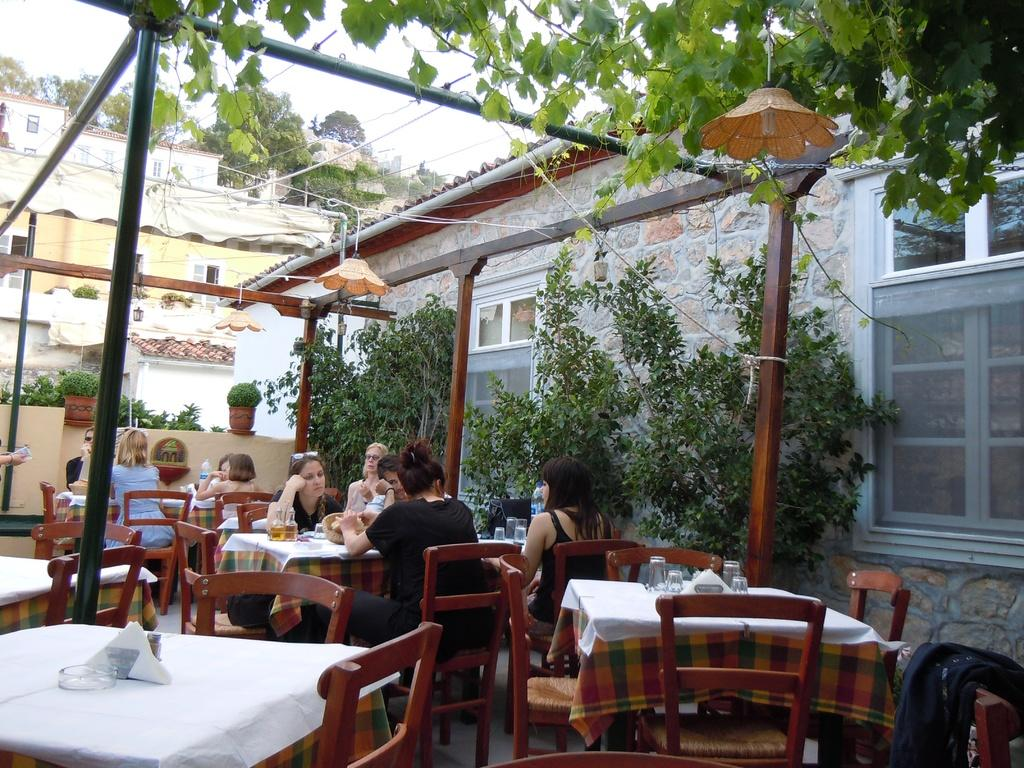What can be seen in the sky in the image? The sky is visible in the image, but no specific details about the sky are mentioned. What type of vegetation is present in the image? There are trees and plants in the image. What type of structures can be seen in the image? There are buildings in the image. What are the people in the image doing? The people are sitting on chairs in the image. What is on the table in the image? There are glasses and plates on the table in the image. What shape is the bean that is sitting on the square in the image? There is no bean or square present in the image. What sense is being used by the people in the image? The provided facts do not mention any specific senses being used by the people in the image. 